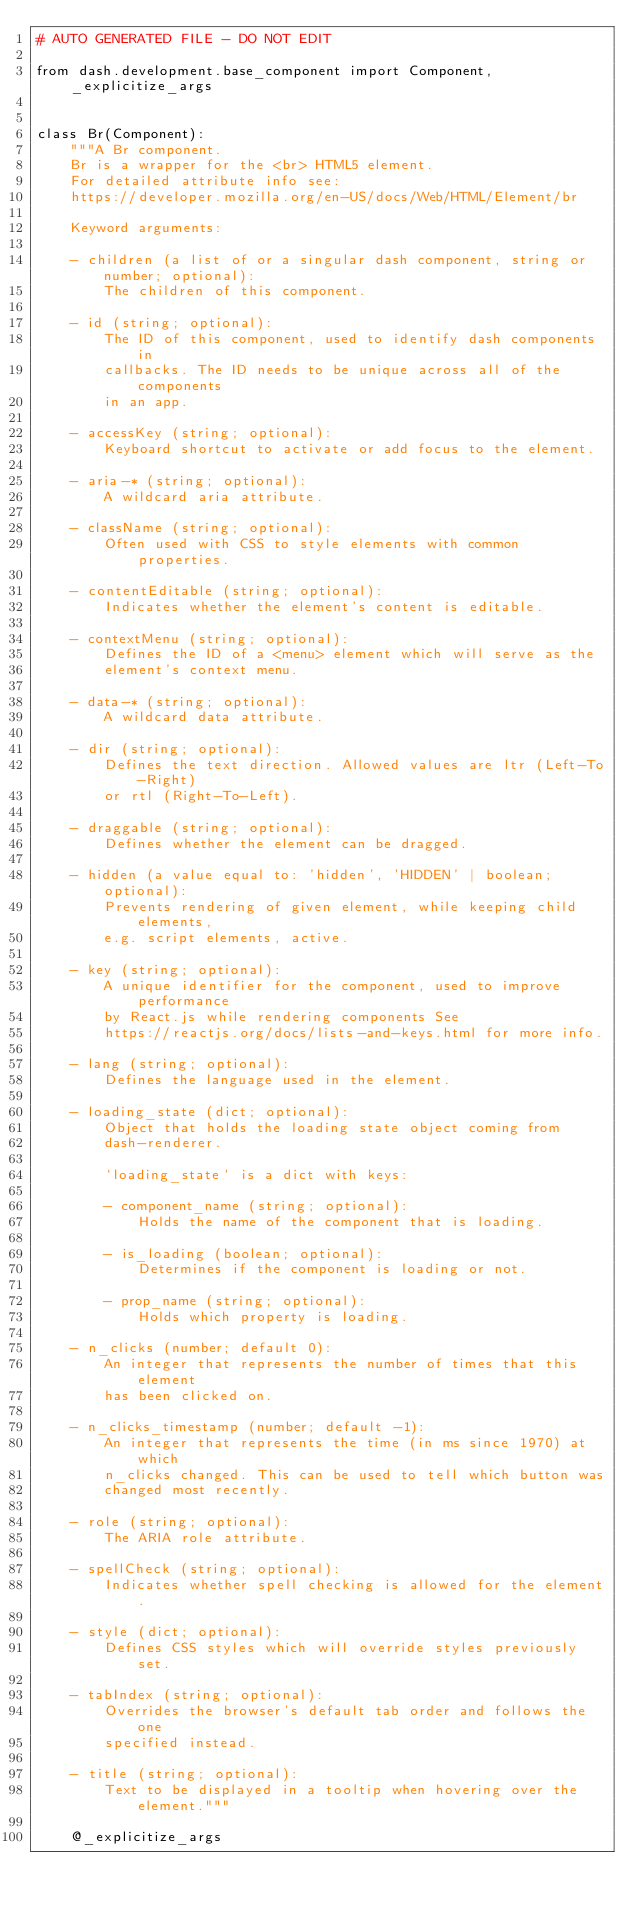<code> <loc_0><loc_0><loc_500><loc_500><_Python_># AUTO GENERATED FILE - DO NOT EDIT

from dash.development.base_component import Component, _explicitize_args


class Br(Component):
    """A Br component.
    Br is a wrapper for the <br> HTML5 element.
    For detailed attribute info see:
    https://developer.mozilla.org/en-US/docs/Web/HTML/Element/br

    Keyword arguments:

    - children (a list of or a singular dash component, string or number; optional):
        The children of this component.

    - id (string; optional):
        The ID of this component, used to identify dash components in
        callbacks. The ID needs to be unique across all of the components
        in an app.

    - accessKey (string; optional):
        Keyboard shortcut to activate or add focus to the element.

    - aria-* (string; optional):
        A wildcard aria attribute.

    - className (string; optional):
        Often used with CSS to style elements with common properties.

    - contentEditable (string; optional):
        Indicates whether the element's content is editable.

    - contextMenu (string; optional):
        Defines the ID of a <menu> element which will serve as the
        element's context menu.

    - data-* (string; optional):
        A wildcard data attribute.

    - dir (string; optional):
        Defines the text direction. Allowed values are ltr (Left-To-Right)
        or rtl (Right-To-Left).

    - draggable (string; optional):
        Defines whether the element can be dragged.

    - hidden (a value equal to: 'hidden', 'HIDDEN' | boolean; optional):
        Prevents rendering of given element, while keeping child elements,
        e.g. script elements, active.

    - key (string; optional):
        A unique identifier for the component, used to improve performance
        by React.js while rendering components See
        https://reactjs.org/docs/lists-and-keys.html for more info.

    - lang (string; optional):
        Defines the language used in the element.

    - loading_state (dict; optional):
        Object that holds the loading state object coming from
        dash-renderer.

        `loading_state` is a dict with keys:

        - component_name (string; optional):
            Holds the name of the component that is loading.

        - is_loading (boolean; optional):
            Determines if the component is loading or not.

        - prop_name (string; optional):
            Holds which property is loading.

    - n_clicks (number; default 0):
        An integer that represents the number of times that this element
        has been clicked on.

    - n_clicks_timestamp (number; default -1):
        An integer that represents the time (in ms since 1970) at which
        n_clicks changed. This can be used to tell which button was
        changed most recently.

    - role (string; optional):
        The ARIA role attribute.

    - spellCheck (string; optional):
        Indicates whether spell checking is allowed for the element.

    - style (dict; optional):
        Defines CSS styles which will override styles previously set.

    - tabIndex (string; optional):
        Overrides the browser's default tab order and follows the one
        specified instead.

    - title (string; optional):
        Text to be displayed in a tooltip when hovering over the element."""

    @_explicitize_args</code> 